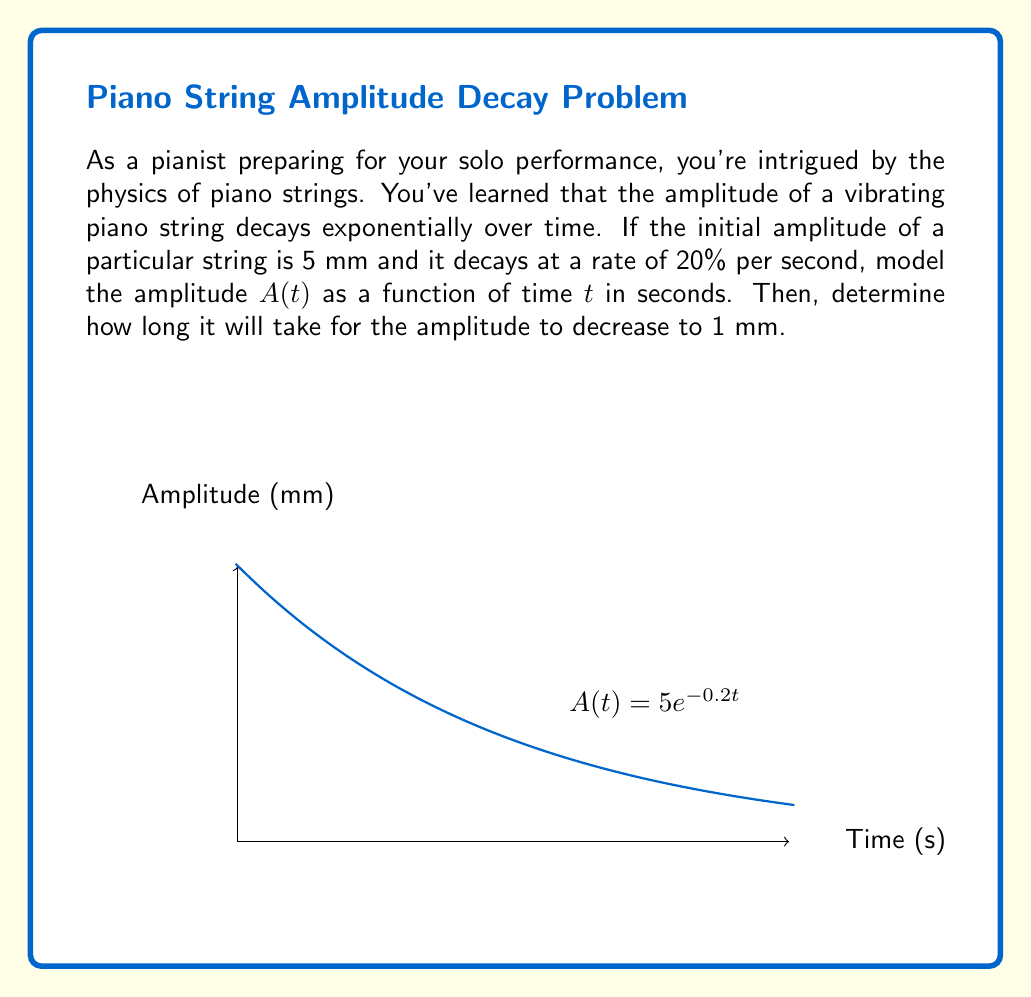Teach me how to tackle this problem. Let's approach this step-by-step:

1) The general form of exponential decay is:
   $$A(t) = A_0e^{-kt}$$
   where $A_0$ is the initial amplitude, $k$ is the decay constant, and $t$ is time.

2) We're given that $A_0 = 5$ mm.

3) The decay rate is 20% per second, which means that after one second, the amplitude is 80% of its original value. We can use this to find $k$:
   $$0.8 = e^{-k(1)}$$
   $$\ln(0.8) = -k$$
   $$k = -\ln(0.8) \approx 0.223$$

4) Therefore, our model is:
   $$A(t) = 5e^{-0.223t}$$

5) To find when the amplitude reaches 1 mm, we solve:
   $$1 = 5e^{-0.223t}$$

6) Taking natural log of both sides:
   $$\ln(1/5) = -0.223t$$

7) Solving for $t$:
   $$t = \frac{\ln(5)}{0.223} \approx 7.24$$

Thus, it will take approximately 7.24 seconds for the amplitude to decrease to 1 mm.
Answer: $A(t) = 5e^{-0.223t}$; 7.24 seconds 